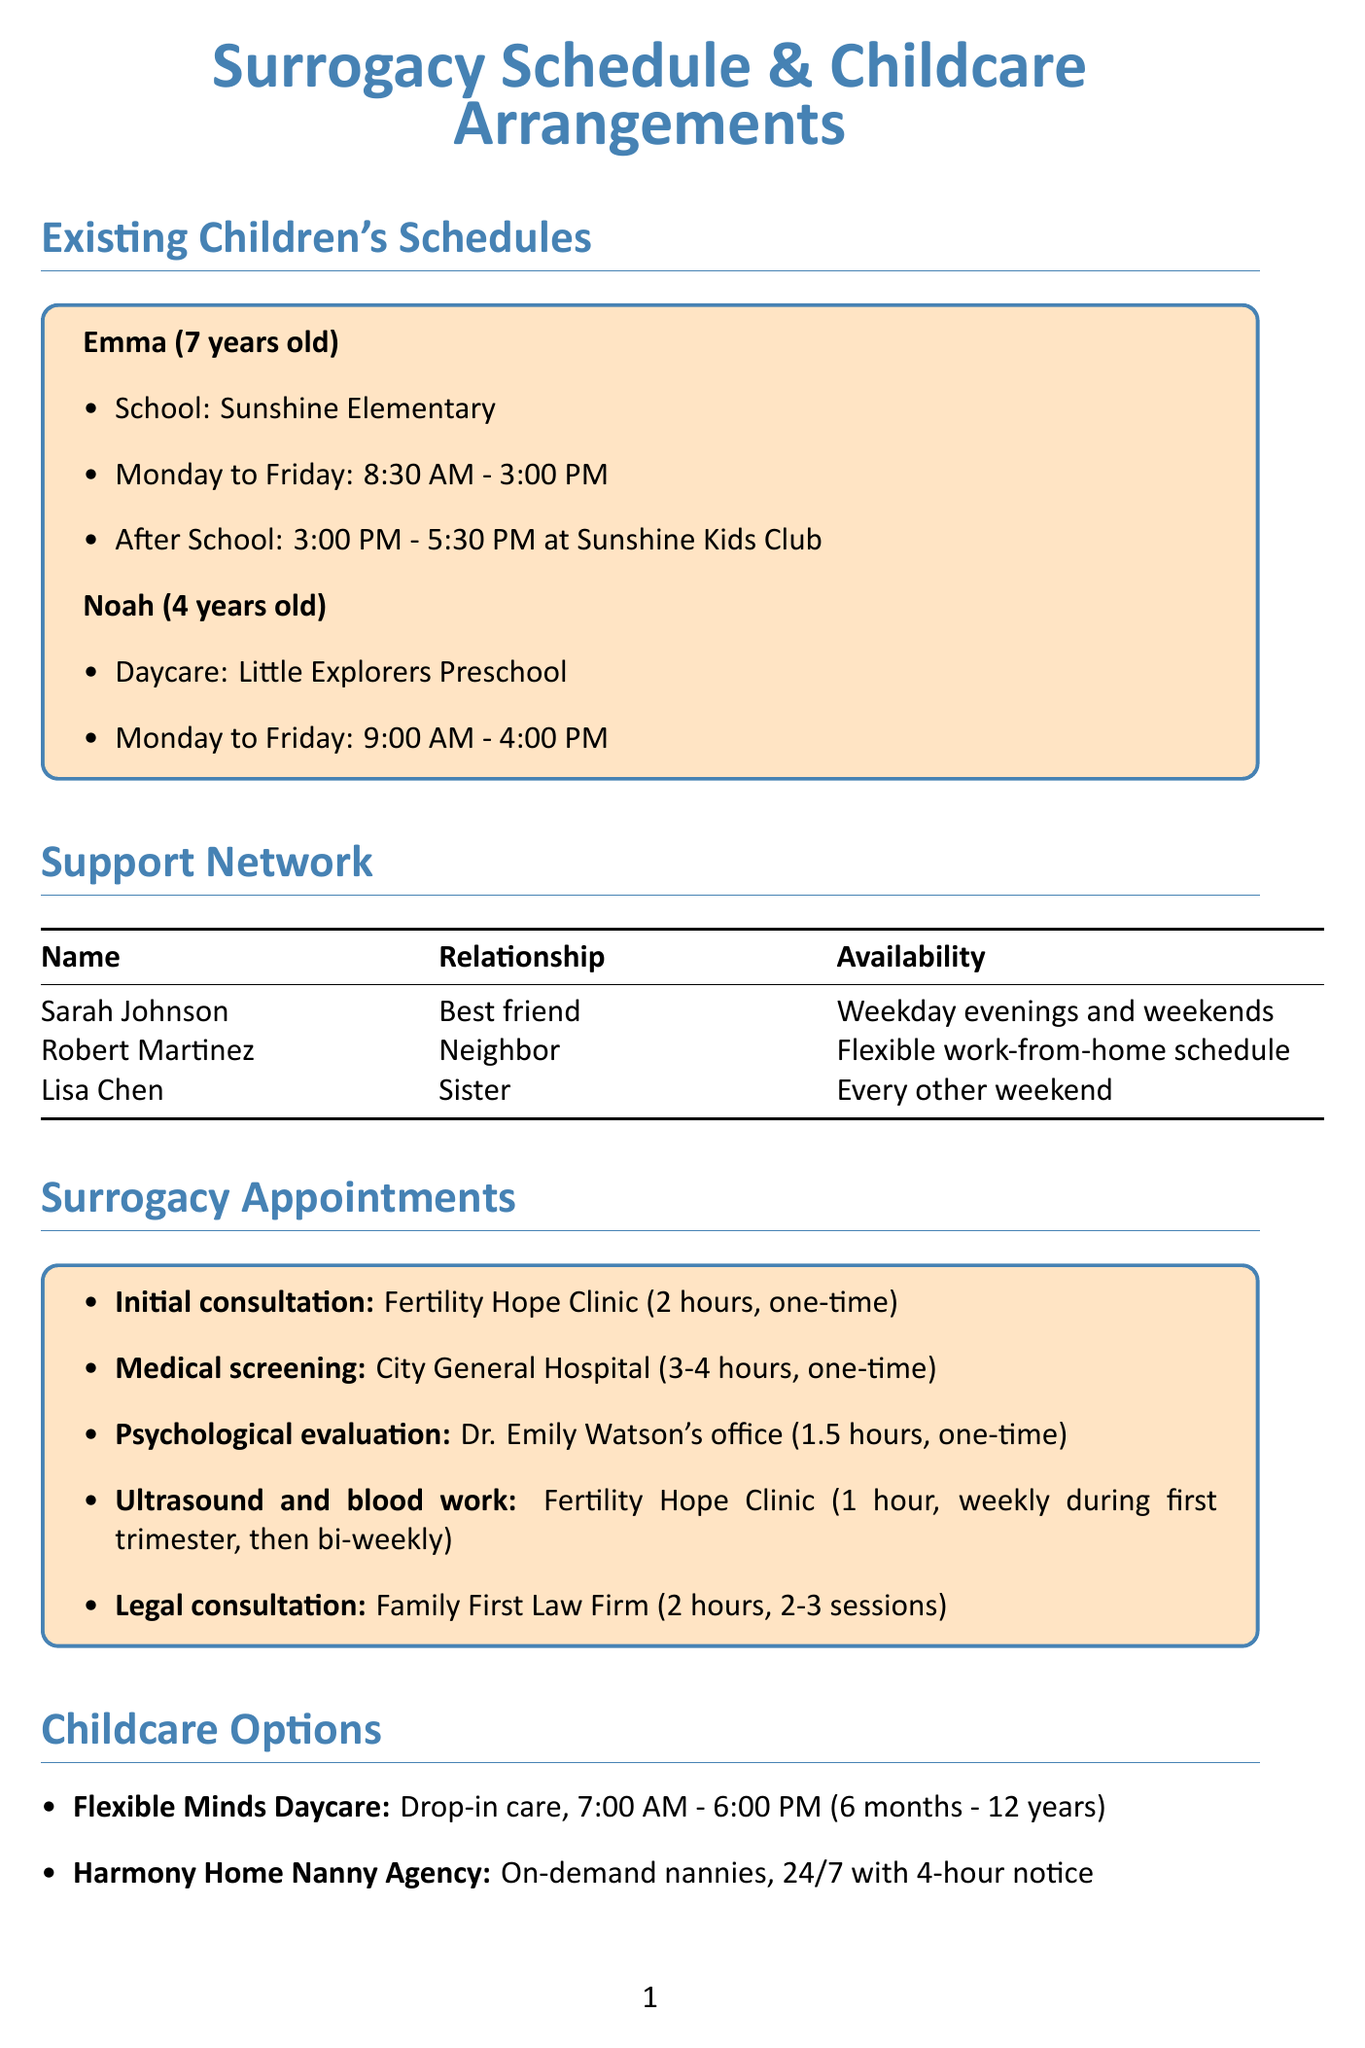What is Emma's school? The document specifies that Emma attends Sunshine Elementary.
Answer: Sunshine Elementary What are the drop-off hours for Flexible Minds Daycare? The document lists the operating hours for Flexible Minds Daycare as 7:00 AM to 6:00 PM.
Answer: 7:00 AM - 6:00 PM During which days can Sarah Johnson provide support? Sarah Johnson's availability is for weekday evenings and weekends, as stated in the support network section.
Answer: Weekday evenings and weekends How long is the medical screening appointment? The medical screening appointment is noted as lasting 3-4 hours in the document.
Answer: 3-4 hours What is the primary role of Dr. Jessica Mills? Dr. Jessica Mills is identified in the emergency contacts as the family pediatrician.
Answer: Family pediatrician Which agency offers 24/7 nanny services? The document indicates that Harmony Home Nanny Agency provides 24/7 on-demand nanny services.
Answer: Harmony Home Nanny Agency What time does Noah's daycare start? According to the document, Noah's daycare, Little Explorers Preschool, starts at 9:00 AM.
Answer: 9:00 AM How many sessions are expected for the legal consultation? The document states that legal consultation will have 2-3 sessions.
Answer: 2-3 sessions What is the phone number for Sunshine Elementary School Office? The emergency contacts section provides the phone number as 555-987-6543.
Answer: 555-987-6543 